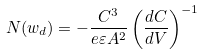Convert formula to latex. <formula><loc_0><loc_0><loc_500><loc_500>N ( w _ { d } ) = - \frac { C ^ { 3 } } { e \varepsilon A ^ { 2 } } \left ( \frac { d C } { d V } \right ) ^ { - 1 }</formula> 